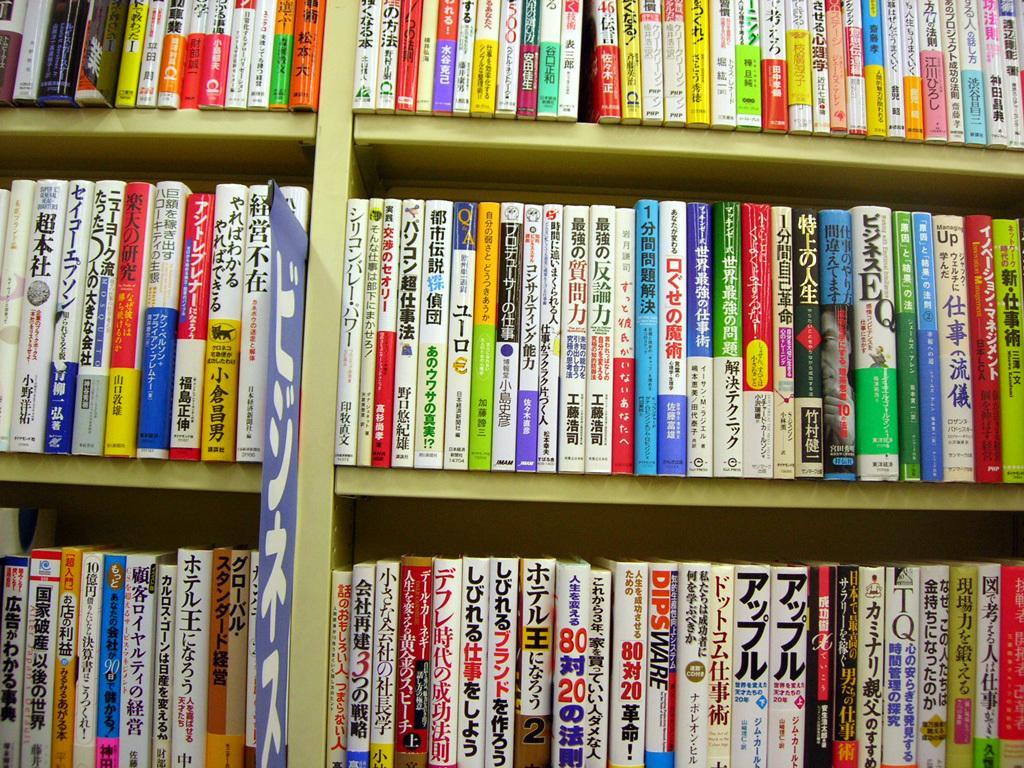Describe this image in one or two sentences. In this picture we can see racks, there are some books present on the racks. 